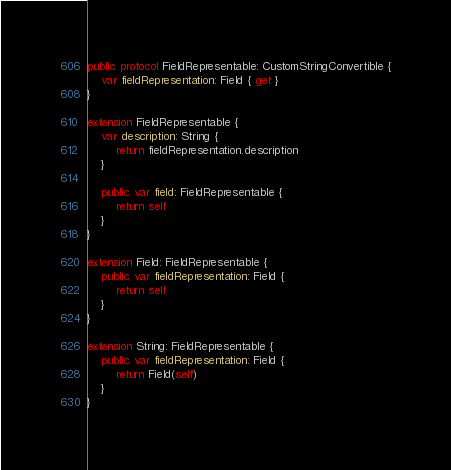<code> <loc_0><loc_0><loc_500><loc_500><_Swift_>public protocol FieldRepresentable: CustomStringConvertible {
    var fieldRepresentation: Field { get }
}

extension FieldRepresentable {
    var description: String {
        return fieldRepresentation.description
    }
    
    public var field: FieldRepresentable {
        return self
    }
}

extension Field: FieldRepresentable {
    public var fieldRepresentation: Field {
        return self
    }
}

extension String: FieldRepresentable {
    public var fieldRepresentation: Field {
        return Field(self)
    }
}
</code> 